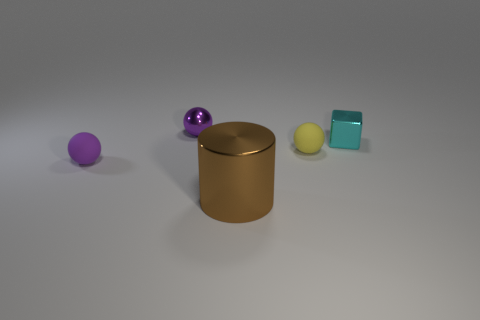Add 2 brown metal things. How many objects exist? 7 Subtract all cylinders. How many objects are left? 4 Subtract all tiny cyan metallic objects. Subtract all tiny purple metal balls. How many objects are left? 3 Add 1 yellow matte things. How many yellow matte things are left? 2 Add 1 brown metallic cylinders. How many brown metallic cylinders exist? 2 Subtract 0 purple cylinders. How many objects are left? 5 